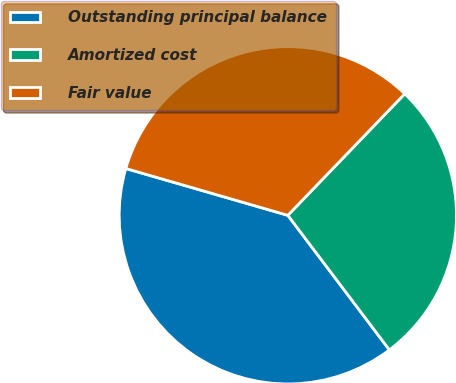Convert chart. <chart><loc_0><loc_0><loc_500><loc_500><pie_chart><fcel>Outstanding principal balance<fcel>Amortized cost<fcel>Fair value<nl><fcel>39.77%<fcel>27.52%<fcel>32.72%<nl></chart> 